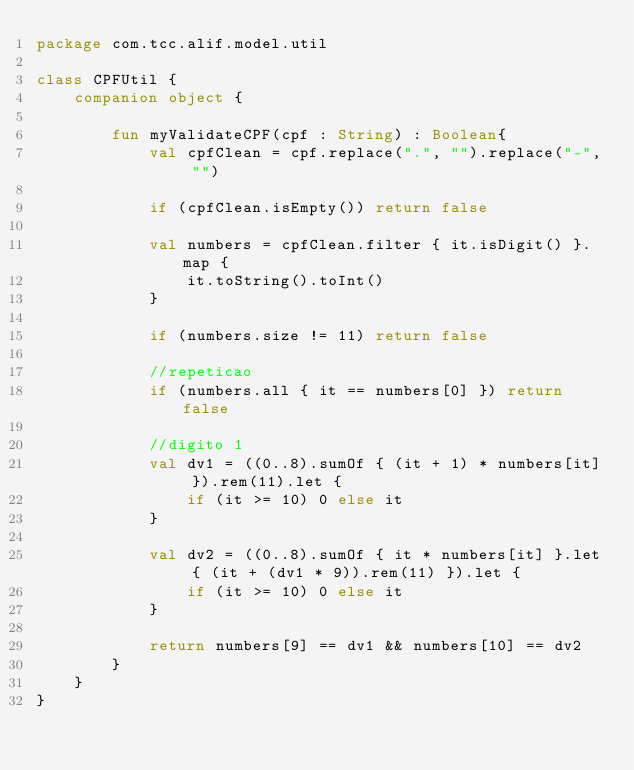<code> <loc_0><loc_0><loc_500><loc_500><_Kotlin_>package com.tcc.alif.model.util

class CPFUtil {
    companion object {

        fun myValidateCPF(cpf : String) : Boolean{
            val cpfClean = cpf.replace(".", "").replace("-", "")

            if (cpfClean.isEmpty()) return false

            val numbers = cpfClean.filter { it.isDigit() }.map {
                it.toString().toInt()
            }

            if (numbers.size != 11) return false

            //repeticao
            if (numbers.all { it == numbers[0] }) return false

            //digito 1
            val dv1 = ((0..8).sumOf { (it + 1) * numbers[it] }).rem(11).let {
                if (it >= 10) 0 else it
            }

            val dv2 = ((0..8).sumOf { it * numbers[it] }.let { (it + (dv1 * 9)).rem(11) }).let {
                if (it >= 10) 0 else it
            }

            return numbers[9] == dv1 && numbers[10] == dv2
        }
    }
}
</code> 